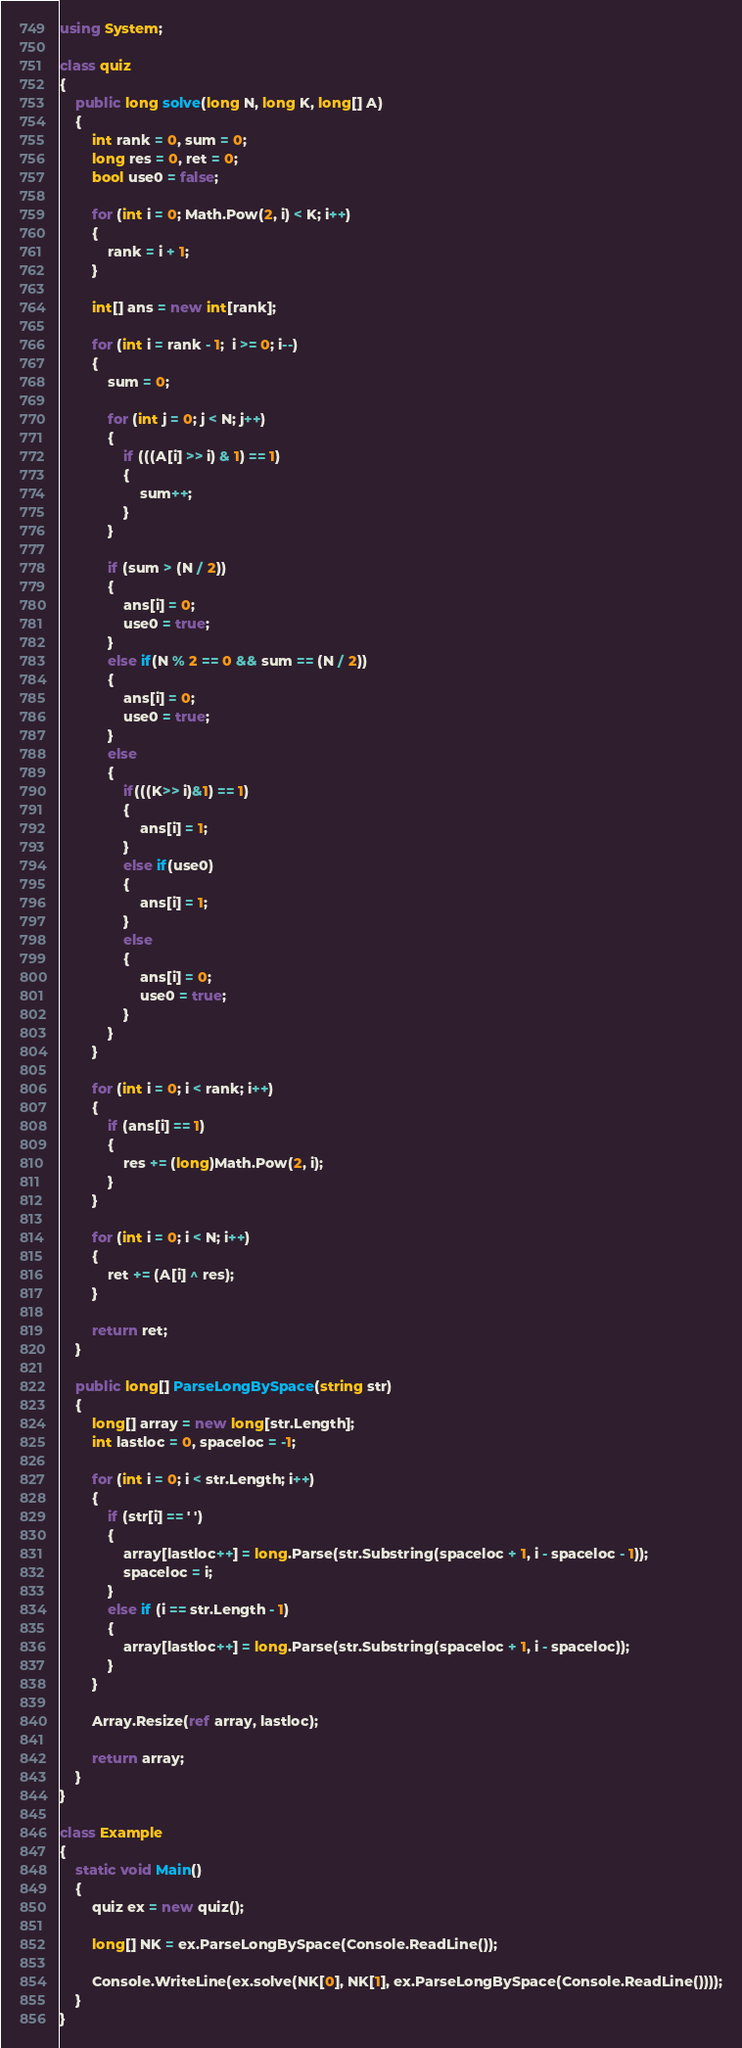<code> <loc_0><loc_0><loc_500><loc_500><_C#_>using System;

class quiz
{
    public long solve(long N, long K, long[] A)
    {
        int rank = 0, sum = 0;
        long res = 0, ret = 0;
        bool use0 = false;

        for (int i = 0; Math.Pow(2, i) < K; i++)
        {
            rank = i + 1;
        }

        int[] ans = new int[rank];

        for (int i = rank - 1;  i >= 0; i--)
        {
            sum = 0;

            for (int j = 0; j < N; j++)
            {
                if (((A[i] >> i) & 1) == 1)
                {
                    sum++;
                }
            }

            if (sum > (N / 2))
            {
                ans[i] = 0;
                use0 = true;
            }
            else if(N % 2 == 0 && sum == (N / 2))
            {
                ans[i] = 0;
                use0 = true;
            }
            else
            {
                if(((K>> i)&1) == 1)
                {
                    ans[i] = 1; 
                }
                else if(use0)
                {
                    ans[i] = 1;
                }
                else
                {
                    ans[i] = 0;
                    use0 = true;
                }
            }
        }

        for (int i = 0; i < rank; i++)
        {
            if (ans[i] == 1)
            {
                res += (long)Math.Pow(2, i);
            }
        }

        for (int i = 0; i < N; i++)
        {
            ret += (A[i] ^ res);
        }

        return ret;
    }

    public long[] ParseLongBySpace(string str)
    {
        long[] array = new long[str.Length];
        int lastloc = 0, spaceloc = -1;

        for (int i = 0; i < str.Length; i++)
        {
            if (str[i] == ' ')
            {
                array[lastloc++] = long.Parse(str.Substring(spaceloc + 1, i - spaceloc - 1));
                spaceloc = i;
            }
            else if (i == str.Length - 1)
            {
                array[lastloc++] = long.Parse(str.Substring(spaceloc + 1, i - spaceloc));
            }
        }

        Array.Resize(ref array, lastloc);

        return array;
    }
}

class Example
{
    static void Main()
    {
        quiz ex = new quiz();

        long[] NK = ex.ParseLongBySpace(Console.ReadLine());

        Console.WriteLine(ex.solve(NK[0], NK[1], ex.ParseLongBySpace(Console.ReadLine())));
    }
}</code> 